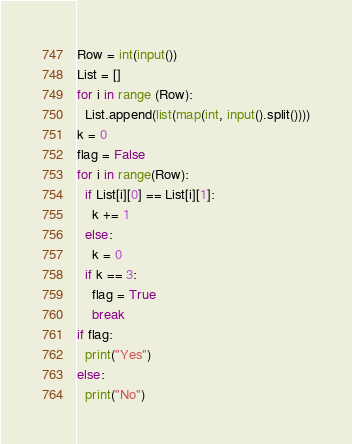<code> <loc_0><loc_0><loc_500><loc_500><_Python_>Row = int(input())
List = []
for i in range (Row):
  List.append(list(map(int, input().split())))
k = 0
flag = False
for i in range(Row):
  if List[i][0] == List[i][1]:
    k += 1
  else:
    k = 0
  if k == 3:
    flag = True
    break
if flag:
  print("Yes")
else:
  print("No")</code> 